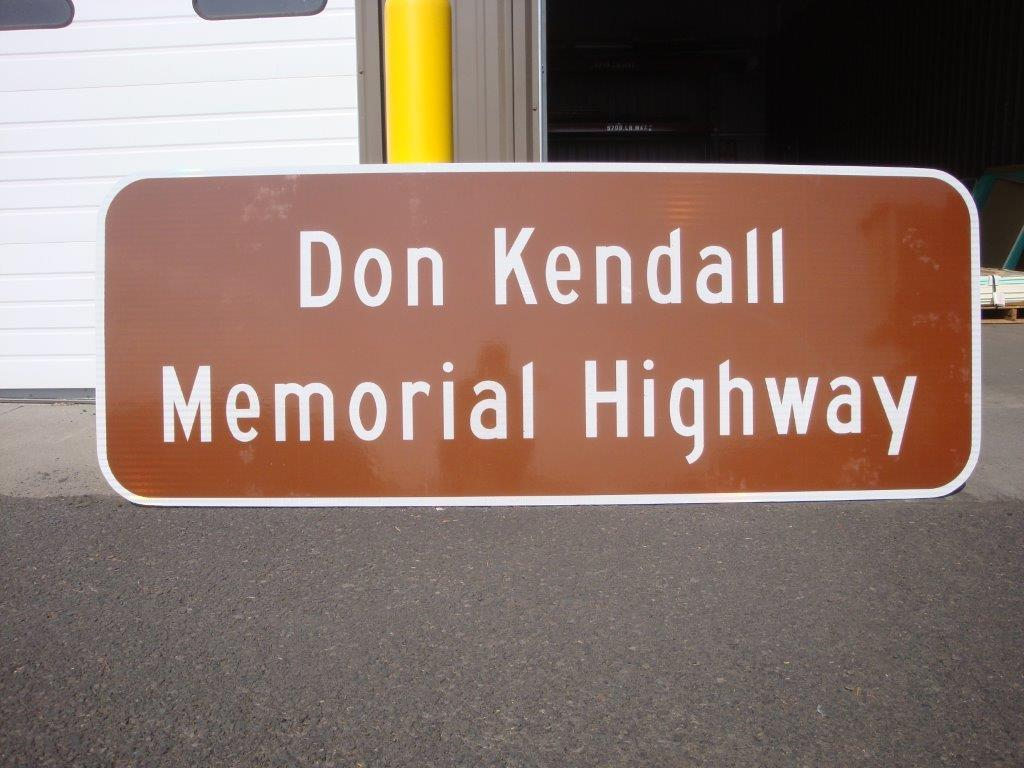<image>
Write a terse but informative summary of the picture. A brown sign in front of a garage that says Don Kendall memorial highway. 